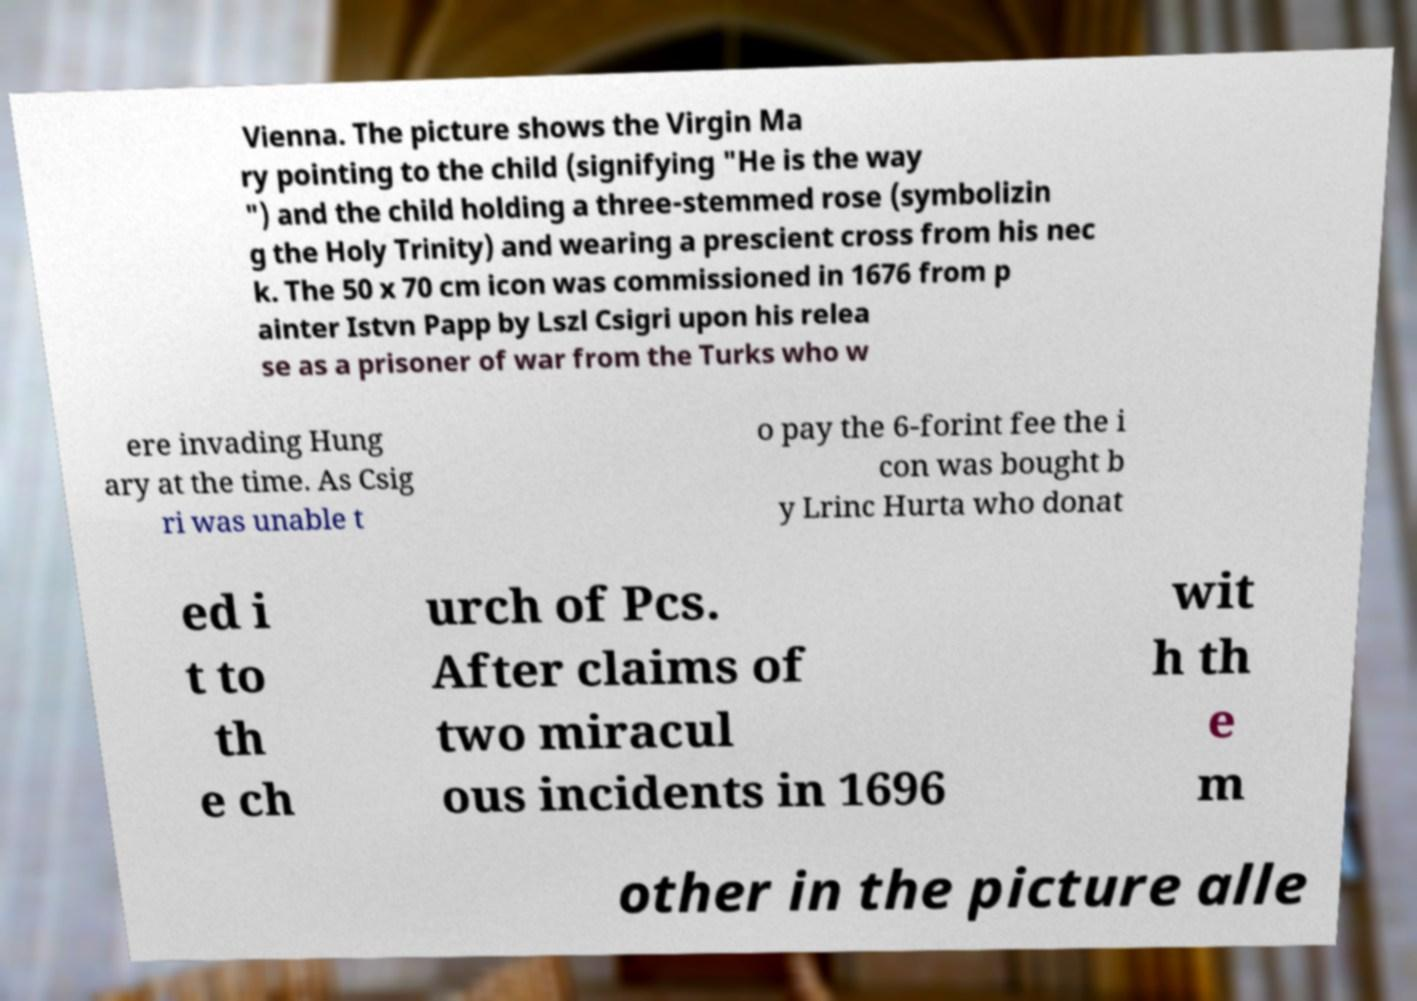Please read and relay the text visible in this image. What does it say? Vienna. The picture shows the Virgin Ma ry pointing to the child (signifying "He is the way ") and the child holding a three-stemmed rose (symbolizin g the Holy Trinity) and wearing a prescient cross from his nec k. The 50 x 70 cm icon was commissioned in 1676 from p ainter Istvn Papp by Lszl Csigri upon his relea se as a prisoner of war from the Turks who w ere invading Hung ary at the time. As Csig ri was unable t o pay the 6-forint fee the i con was bought b y Lrinc Hurta who donat ed i t to th e ch urch of Pcs. After claims of two miracul ous incidents in 1696 wit h th e m other in the picture alle 